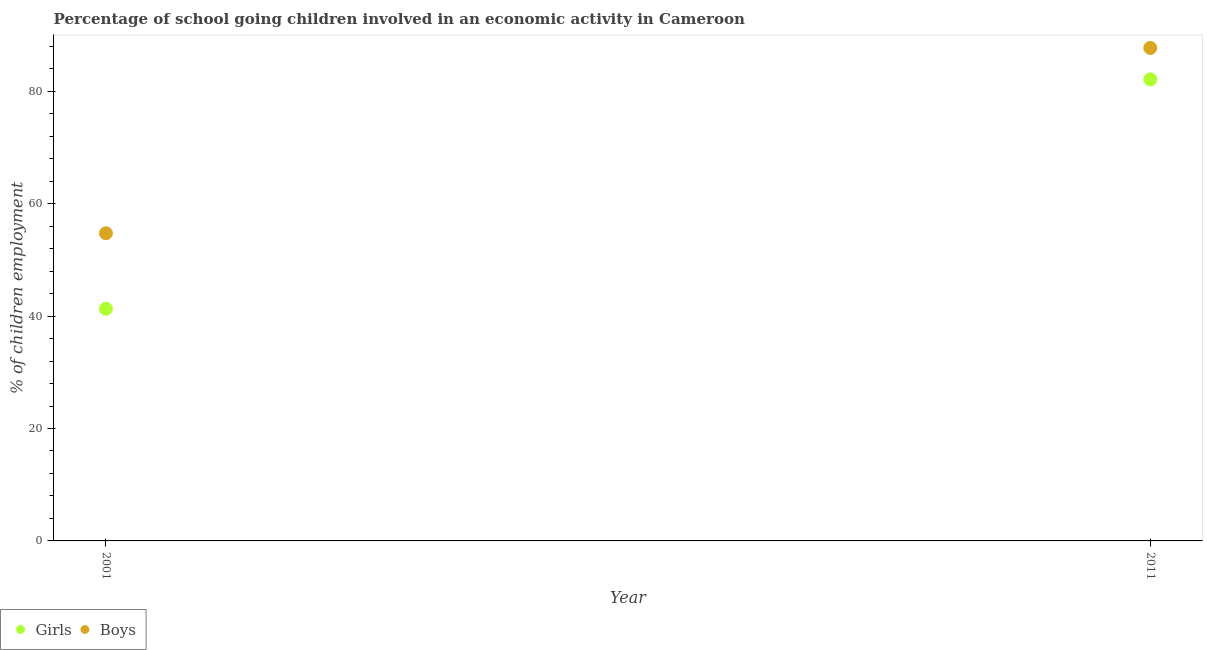How many different coloured dotlines are there?
Provide a succinct answer. 2. What is the percentage of school going girls in 2001?
Keep it short and to the point. 41.3. Across all years, what is the maximum percentage of school going girls?
Provide a short and direct response. 82.1. Across all years, what is the minimum percentage of school going boys?
Your answer should be very brief. 54.73. What is the total percentage of school going boys in the graph?
Keep it short and to the point. 142.43. What is the difference between the percentage of school going boys in 2001 and that in 2011?
Offer a terse response. -32.97. What is the difference between the percentage of school going girls in 2011 and the percentage of school going boys in 2001?
Give a very brief answer. 27.37. What is the average percentage of school going girls per year?
Your response must be concise. 61.7. In the year 2011, what is the difference between the percentage of school going boys and percentage of school going girls?
Give a very brief answer. 5.6. What is the ratio of the percentage of school going girls in 2001 to that in 2011?
Keep it short and to the point. 0.5. Is the percentage of school going boys strictly greater than the percentage of school going girls over the years?
Offer a very short reply. Yes. Is the percentage of school going boys strictly less than the percentage of school going girls over the years?
Ensure brevity in your answer.  No. What is the difference between two consecutive major ticks on the Y-axis?
Your answer should be very brief. 20. Are the values on the major ticks of Y-axis written in scientific E-notation?
Your response must be concise. No. Does the graph contain grids?
Your answer should be compact. No. Where does the legend appear in the graph?
Your answer should be compact. Bottom left. What is the title of the graph?
Provide a succinct answer. Percentage of school going children involved in an economic activity in Cameroon. Does "Commercial bank branches" appear as one of the legend labels in the graph?
Offer a very short reply. No. What is the label or title of the X-axis?
Your response must be concise. Year. What is the label or title of the Y-axis?
Give a very brief answer. % of children employment. What is the % of children employment in Girls in 2001?
Offer a very short reply. 41.3. What is the % of children employment of Boys in 2001?
Offer a terse response. 54.73. What is the % of children employment of Girls in 2011?
Offer a very short reply. 82.1. What is the % of children employment of Boys in 2011?
Provide a succinct answer. 87.7. Across all years, what is the maximum % of children employment in Girls?
Offer a very short reply. 82.1. Across all years, what is the maximum % of children employment of Boys?
Your answer should be compact. 87.7. Across all years, what is the minimum % of children employment of Girls?
Give a very brief answer. 41.3. Across all years, what is the minimum % of children employment of Boys?
Offer a terse response. 54.73. What is the total % of children employment of Girls in the graph?
Ensure brevity in your answer.  123.4. What is the total % of children employment of Boys in the graph?
Provide a short and direct response. 142.43. What is the difference between the % of children employment of Girls in 2001 and that in 2011?
Keep it short and to the point. -40.8. What is the difference between the % of children employment in Boys in 2001 and that in 2011?
Make the answer very short. -32.97. What is the difference between the % of children employment of Girls in 2001 and the % of children employment of Boys in 2011?
Offer a very short reply. -46.4. What is the average % of children employment in Girls per year?
Your response must be concise. 61.7. What is the average % of children employment in Boys per year?
Provide a succinct answer. 71.21. In the year 2001, what is the difference between the % of children employment of Girls and % of children employment of Boys?
Keep it short and to the point. -13.43. In the year 2011, what is the difference between the % of children employment of Girls and % of children employment of Boys?
Provide a succinct answer. -5.6. What is the ratio of the % of children employment of Girls in 2001 to that in 2011?
Keep it short and to the point. 0.5. What is the ratio of the % of children employment of Boys in 2001 to that in 2011?
Give a very brief answer. 0.62. What is the difference between the highest and the second highest % of children employment in Girls?
Provide a short and direct response. 40.8. What is the difference between the highest and the second highest % of children employment of Boys?
Keep it short and to the point. 32.97. What is the difference between the highest and the lowest % of children employment of Girls?
Make the answer very short. 40.8. What is the difference between the highest and the lowest % of children employment of Boys?
Make the answer very short. 32.97. 